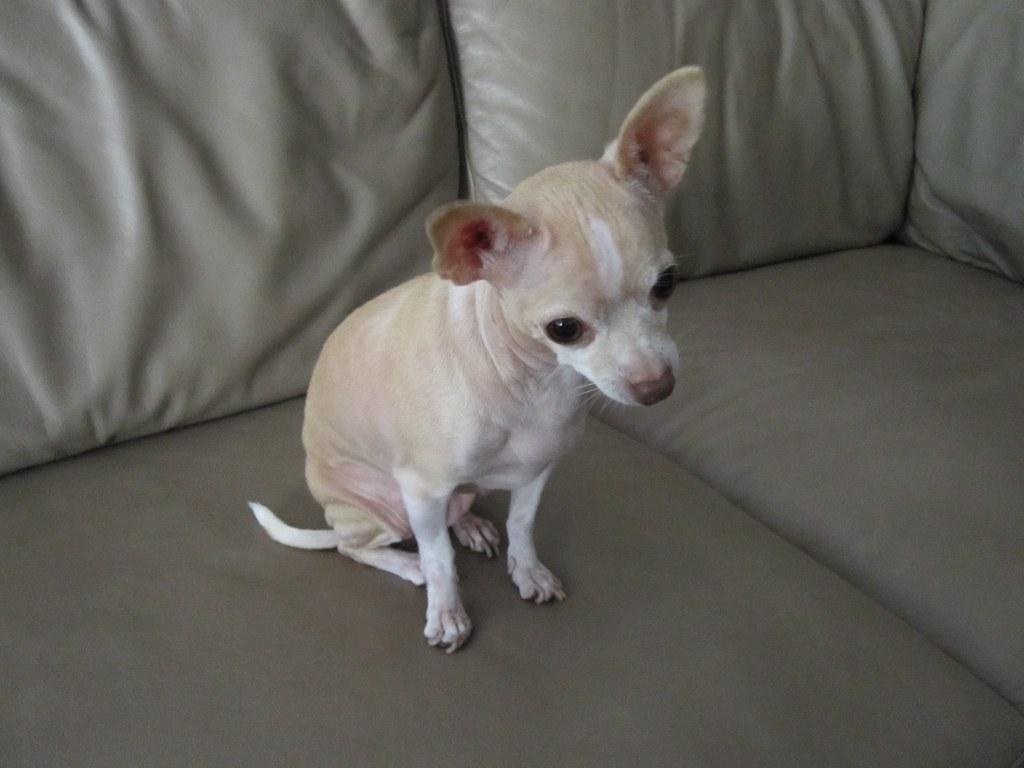Could you give a brief overview of what you see in this image? In this image I can see a dog is sitting on the sofa. 